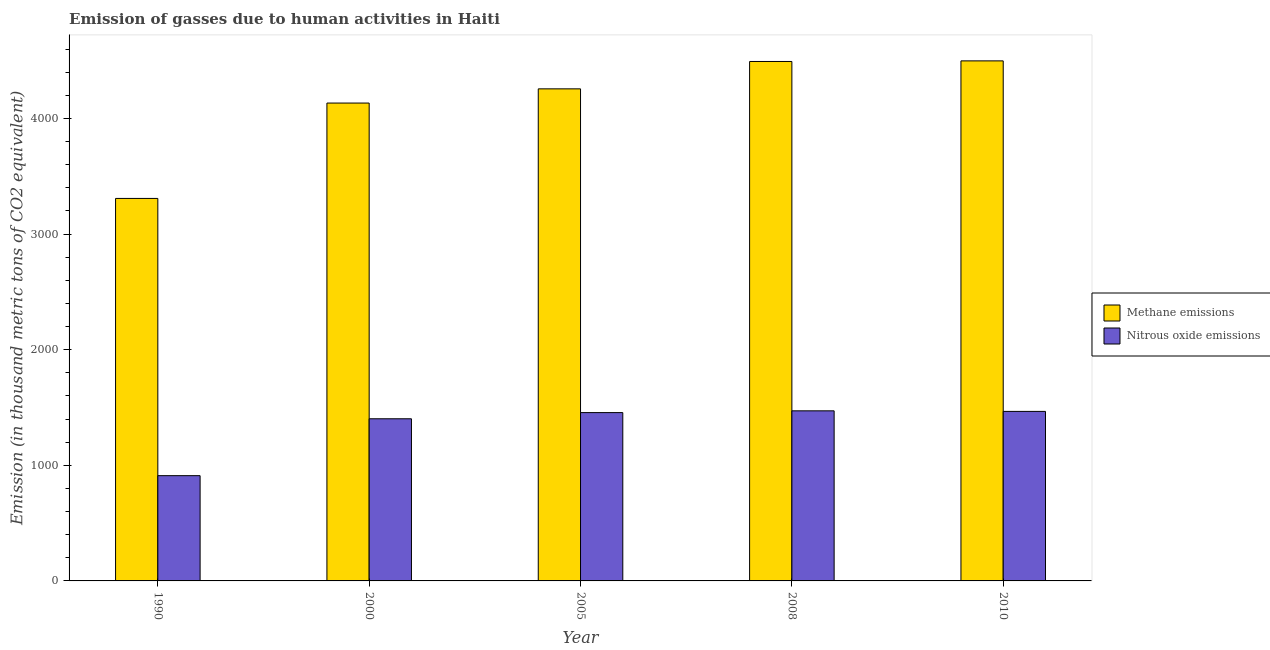How many groups of bars are there?
Give a very brief answer. 5. Are the number of bars per tick equal to the number of legend labels?
Keep it short and to the point. Yes. Are the number of bars on each tick of the X-axis equal?
Make the answer very short. Yes. How many bars are there on the 1st tick from the right?
Ensure brevity in your answer.  2. What is the label of the 5th group of bars from the left?
Make the answer very short. 2010. In how many cases, is the number of bars for a given year not equal to the number of legend labels?
Provide a succinct answer. 0. What is the amount of nitrous oxide emissions in 1990?
Offer a very short reply. 910.3. Across all years, what is the maximum amount of nitrous oxide emissions?
Offer a very short reply. 1470.9. Across all years, what is the minimum amount of nitrous oxide emissions?
Your answer should be compact. 910.3. In which year was the amount of nitrous oxide emissions minimum?
Provide a succinct answer. 1990. What is the total amount of methane emissions in the graph?
Provide a succinct answer. 2.07e+04. What is the difference between the amount of nitrous oxide emissions in 1990 and that in 2000?
Give a very brief answer. -491.9. What is the difference between the amount of methane emissions in 2000 and the amount of nitrous oxide emissions in 2008?
Make the answer very short. -359.5. What is the average amount of methane emissions per year?
Ensure brevity in your answer.  4137.04. In the year 2010, what is the difference between the amount of methane emissions and amount of nitrous oxide emissions?
Your response must be concise. 0. What is the ratio of the amount of nitrous oxide emissions in 2000 to that in 2005?
Offer a terse response. 0.96. What is the difference between the highest and the second highest amount of methane emissions?
Keep it short and to the point. 5.2. What is the difference between the highest and the lowest amount of methane emissions?
Your response must be concise. 1189.5. What does the 2nd bar from the left in 2000 represents?
Your answer should be compact. Nitrous oxide emissions. What does the 1st bar from the right in 2010 represents?
Your answer should be very brief. Nitrous oxide emissions. Are all the bars in the graph horizontal?
Your response must be concise. No. What is the difference between two consecutive major ticks on the Y-axis?
Your response must be concise. 1000. Are the values on the major ticks of Y-axis written in scientific E-notation?
Your response must be concise. No. Does the graph contain grids?
Offer a terse response. No. Where does the legend appear in the graph?
Your answer should be very brief. Center right. What is the title of the graph?
Your answer should be compact. Emission of gasses due to human activities in Haiti. Does "Domestic Liabilities" appear as one of the legend labels in the graph?
Ensure brevity in your answer.  No. What is the label or title of the X-axis?
Provide a succinct answer. Year. What is the label or title of the Y-axis?
Provide a succinct answer. Emission (in thousand metric tons of CO2 equivalent). What is the Emission (in thousand metric tons of CO2 equivalent) of Methane emissions in 1990?
Keep it short and to the point. 3307.8. What is the Emission (in thousand metric tons of CO2 equivalent) of Nitrous oxide emissions in 1990?
Keep it short and to the point. 910.3. What is the Emission (in thousand metric tons of CO2 equivalent) in Methane emissions in 2000?
Offer a very short reply. 4132.6. What is the Emission (in thousand metric tons of CO2 equivalent) of Nitrous oxide emissions in 2000?
Keep it short and to the point. 1402.2. What is the Emission (in thousand metric tons of CO2 equivalent) of Methane emissions in 2005?
Offer a very short reply. 4255.4. What is the Emission (in thousand metric tons of CO2 equivalent) in Nitrous oxide emissions in 2005?
Provide a succinct answer. 1455.6. What is the Emission (in thousand metric tons of CO2 equivalent) of Methane emissions in 2008?
Make the answer very short. 4492.1. What is the Emission (in thousand metric tons of CO2 equivalent) of Nitrous oxide emissions in 2008?
Give a very brief answer. 1470.9. What is the Emission (in thousand metric tons of CO2 equivalent) in Methane emissions in 2010?
Give a very brief answer. 4497.3. What is the Emission (in thousand metric tons of CO2 equivalent) of Nitrous oxide emissions in 2010?
Keep it short and to the point. 1466. Across all years, what is the maximum Emission (in thousand metric tons of CO2 equivalent) of Methane emissions?
Offer a very short reply. 4497.3. Across all years, what is the maximum Emission (in thousand metric tons of CO2 equivalent) in Nitrous oxide emissions?
Provide a succinct answer. 1470.9. Across all years, what is the minimum Emission (in thousand metric tons of CO2 equivalent) of Methane emissions?
Your response must be concise. 3307.8. Across all years, what is the minimum Emission (in thousand metric tons of CO2 equivalent) of Nitrous oxide emissions?
Make the answer very short. 910.3. What is the total Emission (in thousand metric tons of CO2 equivalent) in Methane emissions in the graph?
Ensure brevity in your answer.  2.07e+04. What is the total Emission (in thousand metric tons of CO2 equivalent) of Nitrous oxide emissions in the graph?
Offer a terse response. 6705. What is the difference between the Emission (in thousand metric tons of CO2 equivalent) in Methane emissions in 1990 and that in 2000?
Your response must be concise. -824.8. What is the difference between the Emission (in thousand metric tons of CO2 equivalent) in Nitrous oxide emissions in 1990 and that in 2000?
Keep it short and to the point. -491.9. What is the difference between the Emission (in thousand metric tons of CO2 equivalent) of Methane emissions in 1990 and that in 2005?
Your answer should be very brief. -947.6. What is the difference between the Emission (in thousand metric tons of CO2 equivalent) of Nitrous oxide emissions in 1990 and that in 2005?
Ensure brevity in your answer.  -545.3. What is the difference between the Emission (in thousand metric tons of CO2 equivalent) in Methane emissions in 1990 and that in 2008?
Provide a succinct answer. -1184.3. What is the difference between the Emission (in thousand metric tons of CO2 equivalent) of Nitrous oxide emissions in 1990 and that in 2008?
Offer a very short reply. -560.6. What is the difference between the Emission (in thousand metric tons of CO2 equivalent) in Methane emissions in 1990 and that in 2010?
Provide a short and direct response. -1189.5. What is the difference between the Emission (in thousand metric tons of CO2 equivalent) of Nitrous oxide emissions in 1990 and that in 2010?
Provide a succinct answer. -555.7. What is the difference between the Emission (in thousand metric tons of CO2 equivalent) in Methane emissions in 2000 and that in 2005?
Make the answer very short. -122.8. What is the difference between the Emission (in thousand metric tons of CO2 equivalent) in Nitrous oxide emissions in 2000 and that in 2005?
Provide a short and direct response. -53.4. What is the difference between the Emission (in thousand metric tons of CO2 equivalent) of Methane emissions in 2000 and that in 2008?
Provide a short and direct response. -359.5. What is the difference between the Emission (in thousand metric tons of CO2 equivalent) in Nitrous oxide emissions in 2000 and that in 2008?
Make the answer very short. -68.7. What is the difference between the Emission (in thousand metric tons of CO2 equivalent) of Methane emissions in 2000 and that in 2010?
Your response must be concise. -364.7. What is the difference between the Emission (in thousand metric tons of CO2 equivalent) of Nitrous oxide emissions in 2000 and that in 2010?
Your answer should be very brief. -63.8. What is the difference between the Emission (in thousand metric tons of CO2 equivalent) of Methane emissions in 2005 and that in 2008?
Provide a short and direct response. -236.7. What is the difference between the Emission (in thousand metric tons of CO2 equivalent) of Nitrous oxide emissions in 2005 and that in 2008?
Your response must be concise. -15.3. What is the difference between the Emission (in thousand metric tons of CO2 equivalent) of Methane emissions in 2005 and that in 2010?
Your answer should be compact. -241.9. What is the difference between the Emission (in thousand metric tons of CO2 equivalent) in Nitrous oxide emissions in 2005 and that in 2010?
Give a very brief answer. -10.4. What is the difference between the Emission (in thousand metric tons of CO2 equivalent) of Methane emissions in 2008 and that in 2010?
Your answer should be very brief. -5.2. What is the difference between the Emission (in thousand metric tons of CO2 equivalent) in Nitrous oxide emissions in 2008 and that in 2010?
Provide a succinct answer. 4.9. What is the difference between the Emission (in thousand metric tons of CO2 equivalent) in Methane emissions in 1990 and the Emission (in thousand metric tons of CO2 equivalent) in Nitrous oxide emissions in 2000?
Provide a succinct answer. 1905.6. What is the difference between the Emission (in thousand metric tons of CO2 equivalent) in Methane emissions in 1990 and the Emission (in thousand metric tons of CO2 equivalent) in Nitrous oxide emissions in 2005?
Give a very brief answer. 1852.2. What is the difference between the Emission (in thousand metric tons of CO2 equivalent) of Methane emissions in 1990 and the Emission (in thousand metric tons of CO2 equivalent) of Nitrous oxide emissions in 2008?
Provide a succinct answer. 1836.9. What is the difference between the Emission (in thousand metric tons of CO2 equivalent) of Methane emissions in 1990 and the Emission (in thousand metric tons of CO2 equivalent) of Nitrous oxide emissions in 2010?
Offer a terse response. 1841.8. What is the difference between the Emission (in thousand metric tons of CO2 equivalent) of Methane emissions in 2000 and the Emission (in thousand metric tons of CO2 equivalent) of Nitrous oxide emissions in 2005?
Make the answer very short. 2677. What is the difference between the Emission (in thousand metric tons of CO2 equivalent) of Methane emissions in 2000 and the Emission (in thousand metric tons of CO2 equivalent) of Nitrous oxide emissions in 2008?
Keep it short and to the point. 2661.7. What is the difference between the Emission (in thousand metric tons of CO2 equivalent) of Methane emissions in 2000 and the Emission (in thousand metric tons of CO2 equivalent) of Nitrous oxide emissions in 2010?
Your response must be concise. 2666.6. What is the difference between the Emission (in thousand metric tons of CO2 equivalent) in Methane emissions in 2005 and the Emission (in thousand metric tons of CO2 equivalent) in Nitrous oxide emissions in 2008?
Your answer should be very brief. 2784.5. What is the difference between the Emission (in thousand metric tons of CO2 equivalent) of Methane emissions in 2005 and the Emission (in thousand metric tons of CO2 equivalent) of Nitrous oxide emissions in 2010?
Offer a terse response. 2789.4. What is the difference between the Emission (in thousand metric tons of CO2 equivalent) of Methane emissions in 2008 and the Emission (in thousand metric tons of CO2 equivalent) of Nitrous oxide emissions in 2010?
Give a very brief answer. 3026.1. What is the average Emission (in thousand metric tons of CO2 equivalent) of Methane emissions per year?
Your answer should be compact. 4137.04. What is the average Emission (in thousand metric tons of CO2 equivalent) of Nitrous oxide emissions per year?
Keep it short and to the point. 1341. In the year 1990, what is the difference between the Emission (in thousand metric tons of CO2 equivalent) of Methane emissions and Emission (in thousand metric tons of CO2 equivalent) of Nitrous oxide emissions?
Offer a very short reply. 2397.5. In the year 2000, what is the difference between the Emission (in thousand metric tons of CO2 equivalent) of Methane emissions and Emission (in thousand metric tons of CO2 equivalent) of Nitrous oxide emissions?
Provide a succinct answer. 2730.4. In the year 2005, what is the difference between the Emission (in thousand metric tons of CO2 equivalent) of Methane emissions and Emission (in thousand metric tons of CO2 equivalent) of Nitrous oxide emissions?
Make the answer very short. 2799.8. In the year 2008, what is the difference between the Emission (in thousand metric tons of CO2 equivalent) in Methane emissions and Emission (in thousand metric tons of CO2 equivalent) in Nitrous oxide emissions?
Provide a short and direct response. 3021.2. In the year 2010, what is the difference between the Emission (in thousand metric tons of CO2 equivalent) in Methane emissions and Emission (in thousand metric tons of CO2 equivalent) in Nitrous oxide emissions?
Your answer should be compact. 3031.3. What is the ratio of the Emission (in thousand metric tons of CO2 equivalent) in Methane emissions in 1990 to that in 2000?
Offer a terse response. 0.8. What is the ratio of the Emission (in thousand metric tons of CO2 equivalent) of Nitrous oxide emissions in 1990 to that in 2000?
Offer a terse response. 0.65. What is the ratio of the Emission (in thousand metric tons of CO2 equivalent) in Methane emissions in 1990 to that in 2005?
Keep it short and to the point. 0.78. What is the ratio of the Emission (in thousand metric tons of CO2 equivalent) in Nitrous oxide emissions in 1990 to that in 2005?
Keep it short and to the point. 0.63. What is the ratio of the Emission (in thousand metric tons of CO2 equivalent) of Methane emissions in 1990 to that in 2008?
Provide a short and direct response. 0.74. What is the ratio of the Emission (in thousand metric tons of CO2 equivalent) of Nitrous oxide emissions in 1990 to that in 2008?
Ensure brevity in your answer.  0.62. What is the ratio of the Emission (in thousand metric tons of CO2 equivalent) of Methane emissions in 1990 to that in 2010?
Your answer should be compact. 0.74. What is the ratio of the Emission (in thousand metric tons of CO2 equivalent) of Nitrous oxide emissions in 1990 to that in 2010?
Make the answer very short. 0.62. What is the ratio of the Emission (in thousand metric tons of CO2 equivalent) in Methane emissions in 2000 to that in 2005?
Offer a very short reply. 0.97. What is the ratio of the Emission (in thousand metric tons of CO2 equivalent) of Nitrous oxide emissions in 2000 to that in 2005?
Give a very brief answer. 0.96. What is the ratio of the Emission (in thousand metric tons of CO2 equivalent) of Nitrous oxide emissions in 2000 to that in 2008?
Make the answer very short. 0.95. What is the ratio of the Emission (in thousand metric tons of CO2 equivalent) of Methane emissions in 2000 to that in 2010?
Provide a short and direct response. 0.92. What is the ratio of the Emission (in thousand metric tons of CO2 equivalent) of Nitrous oxide emissions in 2000 to that in 2010?
Make the answer very short. 0.96. What is the ratio of the Emission (in thousand metric tons of CO2 equivalent) of Methane emissions in 2005 to that in 2008?
Your answer should be very brief. 0.95. What is the ratio of the Emission (in thousand metric tons of CO2 equivalent) in Methane emissions in 2005 to that in 2010?
Offer a very short reply. 0.95. What is the ratio of the Emission (in thousand metric tons of CO2 equivalent) in Nitrous oxide emissions in 2005 to that in 2010?
Your answer should be very brief. 0.99. What is the ratio of the Emission (in thousand metric tons of CO2 equivalent) in Methane emissions in 2008 to that in 2010?
Your response must be concise. 1. What is the difference between the highest and the second highest Emission (in thousand metric tons of CO2 equivalent) of Nitrous oxide emissions?
Offer a terse response. 4.9. What is the difference between the highest and the lowest Emission (in thousand metric tons of CO2 equivalent) in Methane emissions?
Make the answer very short. 1189.5. What is the difference between the highest and the lowest Emission (in thousand metric tons of CO2 equivalent) in Nitrous oxide emissions?
Offer a very short reply. 560.6. 